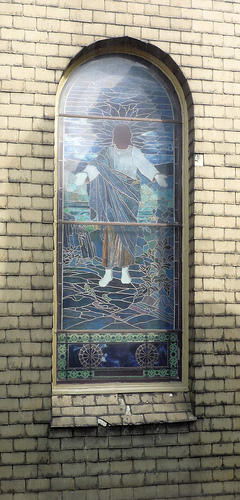<image>
Is the man in the stained glass? Yes. The man is contained within or inside the stained glass, showing a containment relationship. 